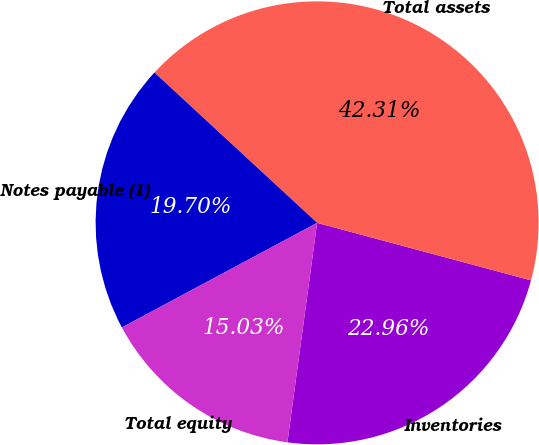<chart> <loc_0><loc_0><loc_500><loc_500><pie_chart><fcel>Inventories<fcel>Total assets<fcel>Notes payable (1)<fcel>Total equity<nl><fcel>22.96%<fcel>42.31%<fcel>19.7%<fcel>15.03%<nl></chart> 